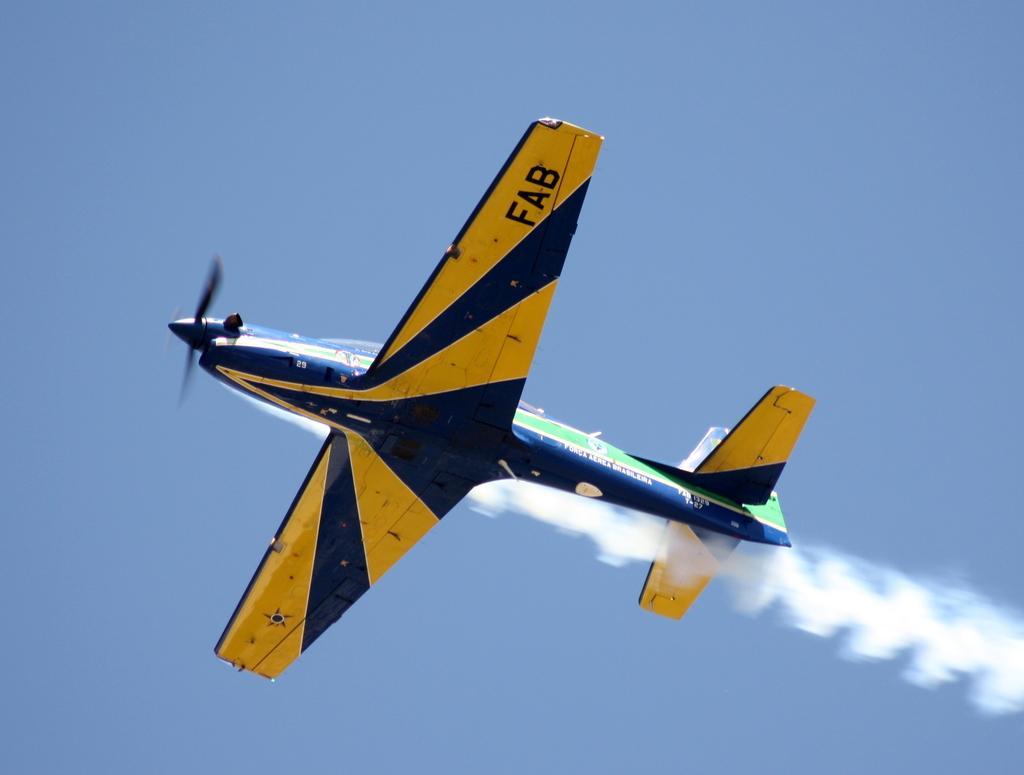In one or two sentences, can you explain what this image depicts? In this picture I can see an aircraft flying in the sky. 